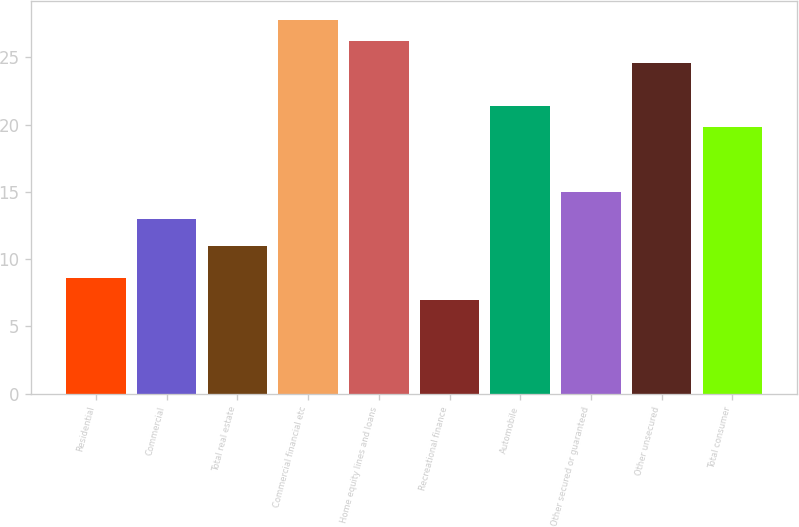<chart> <loc_0><loc_0><loc_500><loc_500><bar_chart><fcel>Residential<fcel>Commercial<fcel>Total real estate<fcel>Commercial financial etc<fcel>Home equity lines and loans<fcel>Recreational finance<fcel>Automobile<fcel>Other secured or guaranteed<fcel>Other unsecured<fcel>Total consumer<nl><fcel>8.6<fcel>13<fcel>11<fcel>27.8<fcel>26.2<fcel>7<fcel>21.4<fcel>15<fcel>24.6<fcel>19.8<nl></chart> 